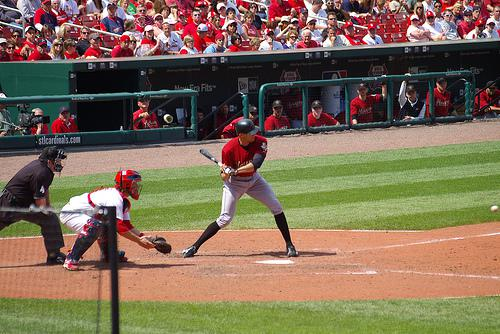Question: where was this photographed?
Choices:
A. Tennis court.
B. Baseball field.
C. A beach.
D. A soccer field.
Answer with the letter. Answer: B Question: what color are the pants of the batter?
Choices:
A. Black.
B. Red.
C. White.
D. Yellow.
Answer with the letter. Answer: C 